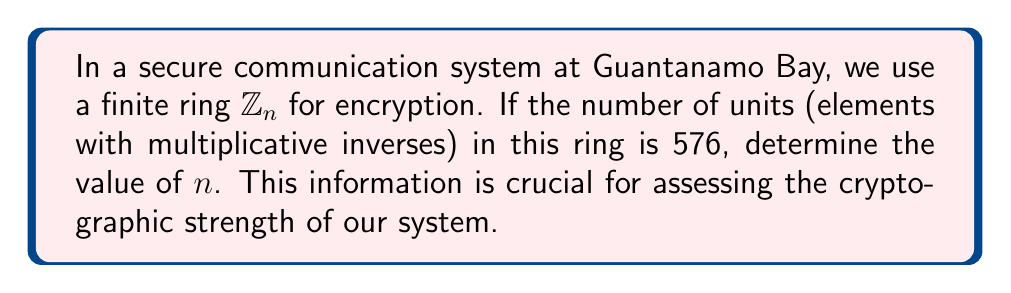Could you help me with this problem? Let's approach this step-by-step:

1) In the ring $\mathbb{Z}_n$, an element $a$ is a unit if and only if $\gcd(a,n) = 1$.

2) The number of units in $\mathbb{Z}_n$ is given by Euler's totient function $\phi(n)$.

3) We are given that $\phi(n) = 576$.

4) To find $n$, we need to factor 576:
   $576 = 2^6 \times 3^2$

5) The possible prime factors of $n$ are 2 and 3.

6) For $\phi(n)$ to be 576, $n$ must be of the form $2^a \times 3^b$ where $a \geq 7$ and $b \geq 3$.

7) The smallest such $n$ is $2^7 \times 3^3 = 128 \times 27 = 3456$.

8) Let's verify:
   $\phi(3456) = \phi(2^7 \times 3^3) = \phi(2^7) \times \phi(3^3)$
                $= (2^7 - 2^6) \times (3^3 - 3^2)$
                $= 64 \times 18 = 576$

Therefore, the smallest value of $n$ that satisfies the condition is 3456.
Answer: $n = 3456$ 